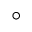<formula> <loc_0><loc_0><loc_500><loc_500>^ { \circ }</formula> 